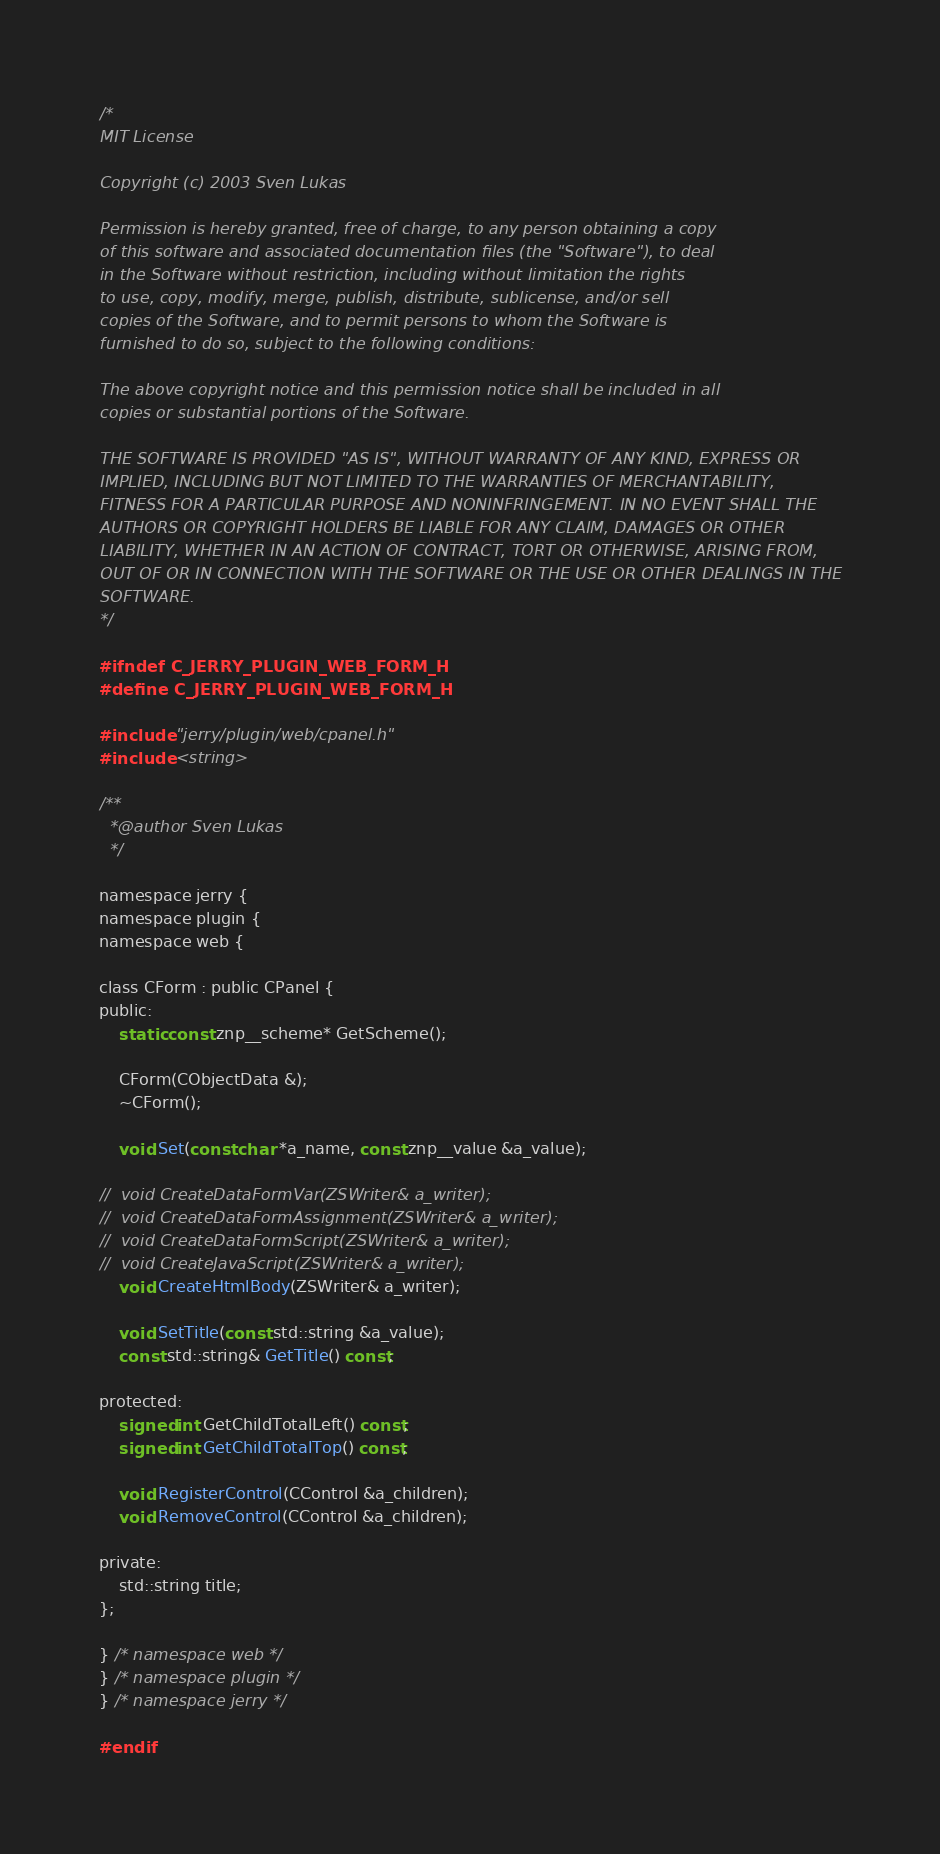<code> <loc_0><loc_0><loc_500><loc_500><_C_>/*
MIT License

Copyright (c) 2003 Sven Lukas

Permission is hereby granted, free of charge, to any person obtaining a copy
of this software and associated documentation files (the "Software"), to deal
in the Software without restriction, including without limitation the rights
to use, copy, modify, merge, publish, distribute, sublicense, and/or sell
copies of the Software, and to permit persons to whom the Software is
furnished to do so, subject to the following conditions:

The above copyright notice and this permission notice shall be included in all
copies or substantial portions of the Software.

THE SOFTWARE IS PROVIDED "AS IS", WITHOUT WARRANTY OF ANY KIND, EXPRESS OR
IMPLIED, INCLUDING BUT NOT LIMITED TO THE WARRANTIES OF MERCHANTABILITY,
FITNESS FOR A PARTICULAR PURPOSE AND NONINFRINGEMENT. IN NO EVENT SHALL THE
AUTHORS OR COPYRIGHT HOLDERS BE LIABLE FOR ANY CLAIM, DAMAGES OR OTHER
LIABILITY, WHETHER IN AN ACTION OF CONTRACT, TORT OR OTHERWISE, ARISING FROM,
OUT OF OR IN CONNECTION WITH THE SOFTWARE OR THE USE OR OTHER DEALINGS IN THE
SOFTWARE.
*/

#ifndef C_JERRY_PLUGIN_WEB_FORM_H
#define C_JERRY_PLUGIN_WEB_FORM_H

#include "jerry/plugin/web/cpanel.h"
#include <string>

/**
  *@author Sven Lukas
  */

namespace jerry {
namespace plugin {
namespace web {

class CForm : public CPanel {
public:
	static const znp__scheme* GetScheme();

	CForm(CObjectData &);
	~CForm();

	void Set(const char *a_name, const znp__value &a_value);

//	void CreateDataFormVar(ZSWriter& a_writer);
//	void CreateDataFormAssignment(ZSWriter& a_writer);
//	void CreateDataFormScript(ZSWriter& a_writer);
//	void CreateJavaScript(ZSWriter& a_writer);
	void CreateHtmlBody(ZSWriter& a_writer);

	void SetTitle(const std::string &a_value);
	const std::string& GetTitle() const;

protected:
	signed int GetChildTotalLeft() const;
	signed int GetChildTotalTop() const;

	void RegisterControl(CControl &a_children);
	void RemoveControl(CControl &a_children);

private:
	std::string title;
};

} /* namespace web */
} /* namespace plugin */
} /* namespace jerry */

#endif
</code> 